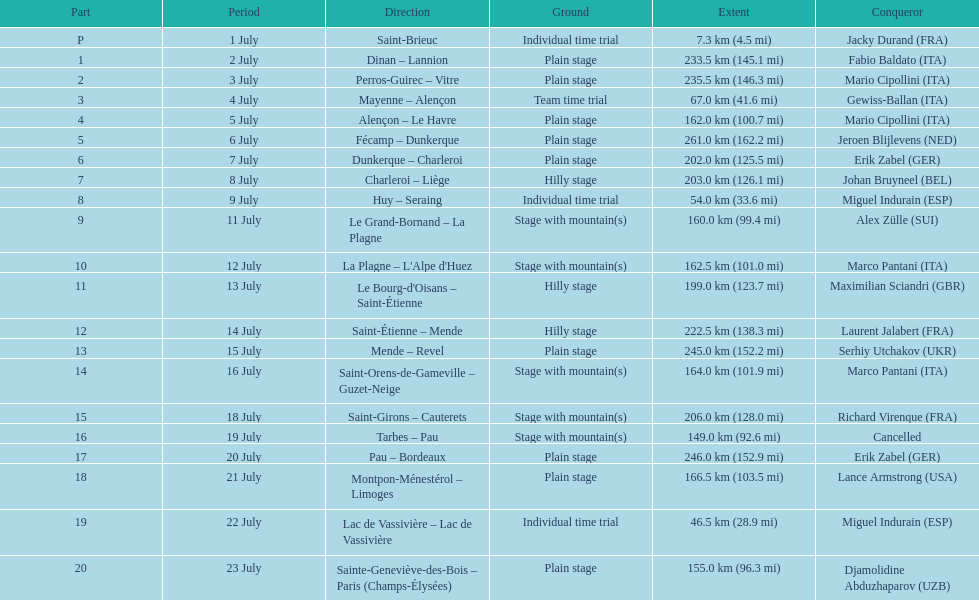What were the dates of the 1995 tour de france? 1 July, 2 July, 3 July, 4 July, 5 July, 6 July, 7 July, 8 July, 9 July, 11 July, 12 July, 13 July, 14 July, 15 July, 16 July, 18 July, 19 July, 20 July, 21 July, 22 July, 23 July. What was the length for july 8th? 203.0 km (126.1 mi). 